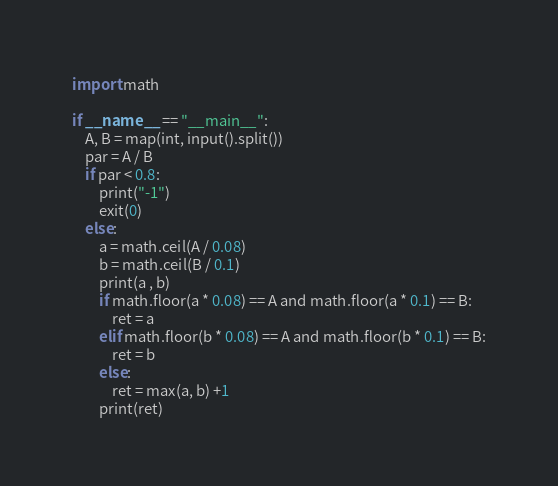<code> <loc_0><loc_0><loc_500><loc_500><_Python_>import math

if __name__ == "__main__":
    A, B = map(int, input().split())
    par = A / B
    if par < 0.8:
        print("-1")
        exit(0)
    else:
        a = math.ceil(A / 0.08)
        b = math.ceil(B / 0.1)
        print(a , b)
        if math.floor(a * 0.08) == A and math.floor(a * 0.1) == B:
            ret = a
        elif math.floor(b * 0.08) == A and math.floor(b * 0.1) == B:
            ret = b
        else:
            ret = max(a, b) +1
        print(ret)</code> 